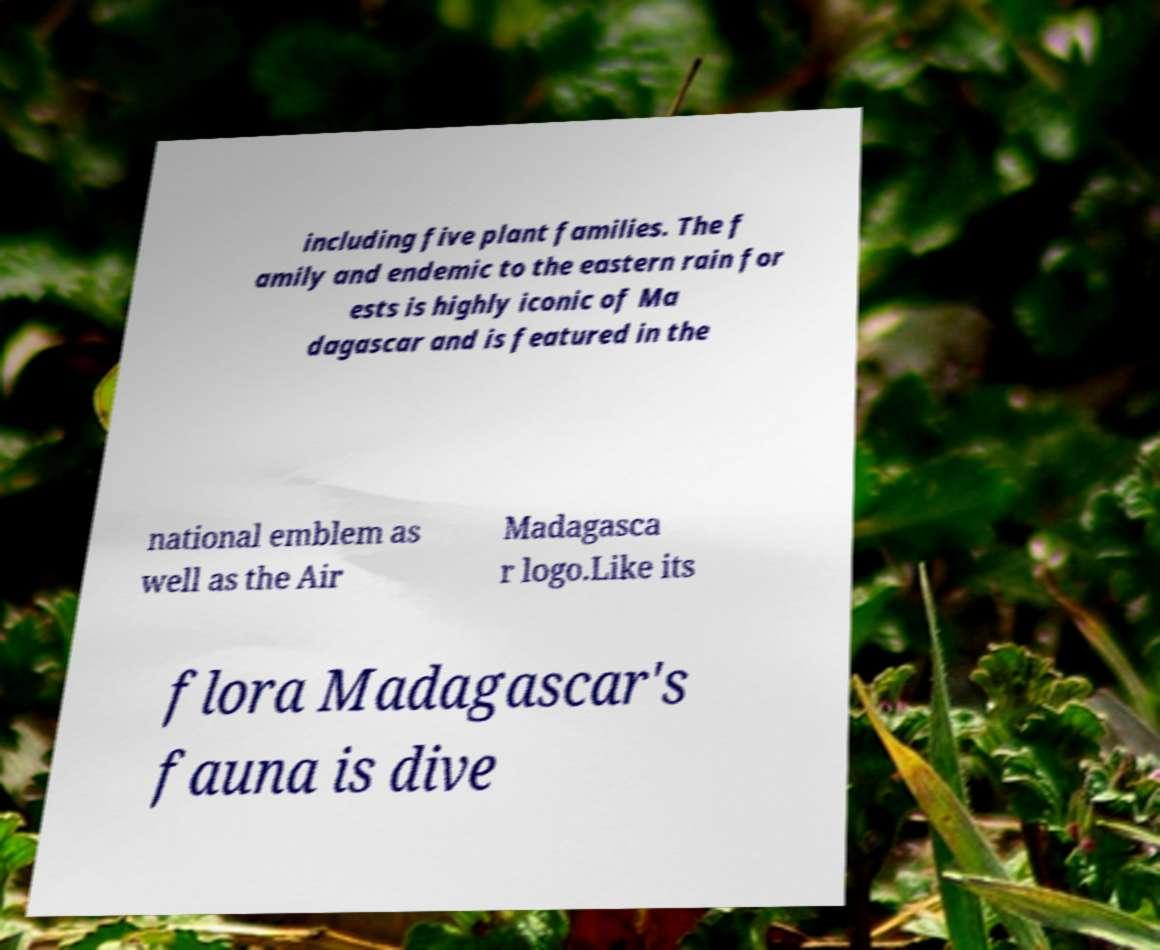Can you accurately transcribe the text from the provided image for me? including five plant families. The f amily and endemic to the eastern rain for ests is highly iconic of Ma dagascar and is featured in the national emblem as well as the Air Madagasca r logo.Like its flora Madagascar's fauna is dive 